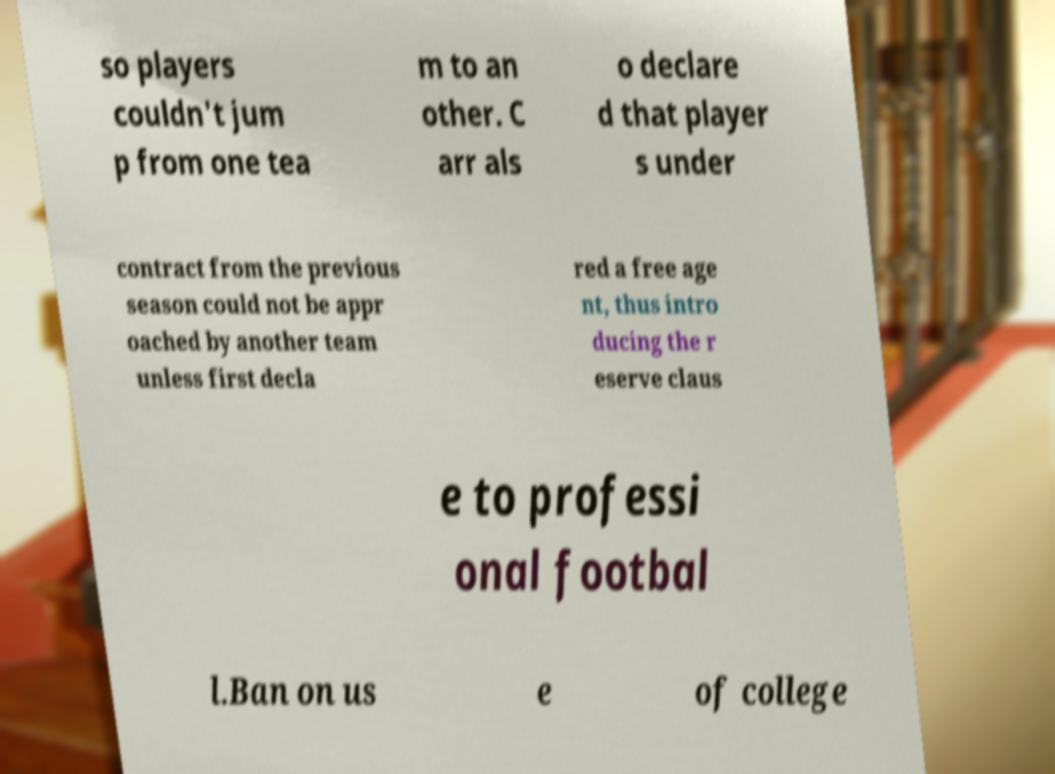Can you accurately transcribe the text from the provided image for me? so players couldn't jum p from one tea m to an other. C arr als o declare d that player s under contract from the previous season could not be appr oached by another team unless first decla red a free age nt, thus intro ducing the r eserve claus e to professi onal footbal l.Ban on us e of college 